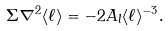Convert formula to latex. <formula><loc_0><loc_0><loc_500><loc_500>\Sigma \nabla ^ { 2 } \langle \ell \rangle = - 2 A _ { l } \langle \ell \rangle ^ { - 3 } .</formula> 